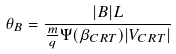<formula> <loc_0><loc_0><loc_500><loc_500>\theta _ { B } = \frac { | B | L } { \frac { m } { q } \Psi ( \beta _ { C R T } ) | V _ { C R T } | }</formula> 